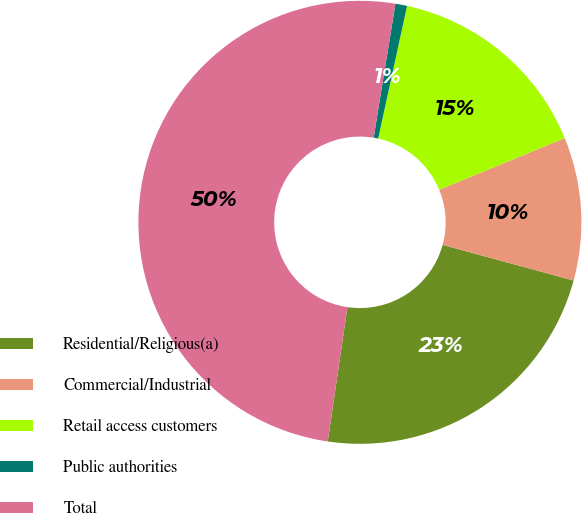Convert chart to OTSL. <chart><loc_0><loc_0><loc_500><loc_500><pie_chart><fcel>Residential/Religious(a)<fcel>Commercial/Industrial<fcel>Retail access customers<fcel>Public authorities<fcel>Total<nl><fcel>23.09%<fcel>10.44%<fcel>15.38%<fcel>0.85%<fcel>50.25%<nl></chart> 